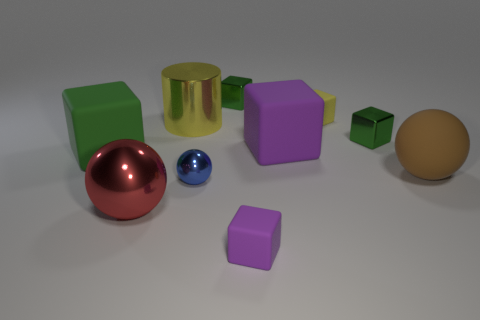Is there a pattern in the arrangement of these objects? The objects appear to be randomly placed, without a discernible pattern in their arrangement. They are spread across the surface with varying spaces in between, suggesting no intentional order. 